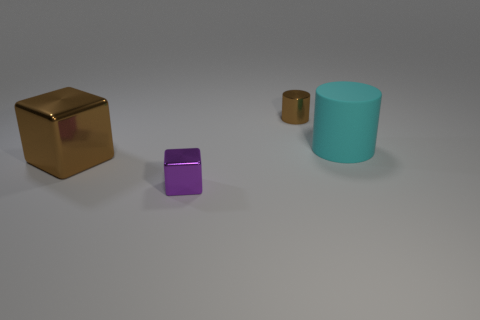Which object in the image appears to be the largest? The cyan-colored cylinder appears to be the largest object in the image, both in terms of height and volume. 